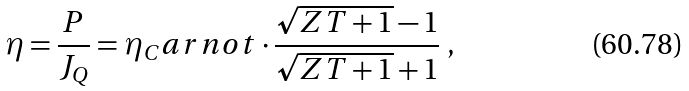Convert formula to latex. <formula><loc_0><loc_0><loc_500><loc_500>\eta = \frac { P } { J _ { Q } } = \eta _ { C } a r n o t \cdot \frac { \sqrt { Z T + 1 } - 1 } { \sqrt { Z T + 1 } + 1 } \ ,</formula> 